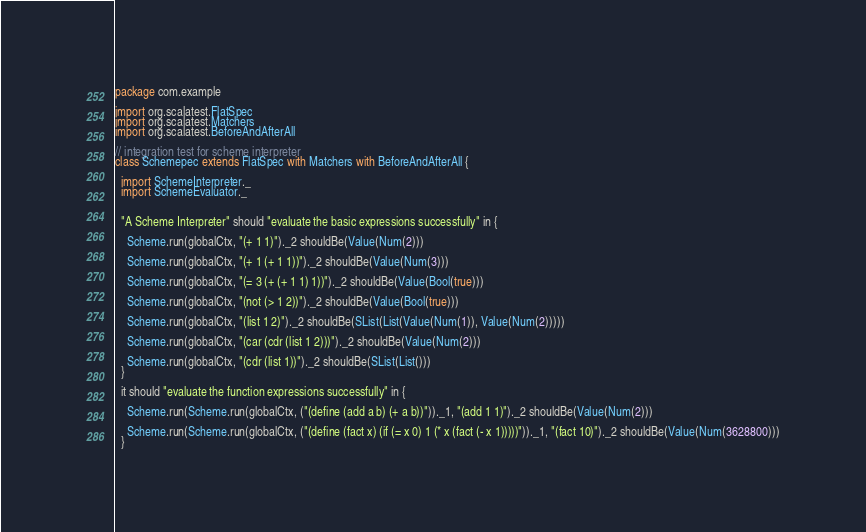Convert code to text. <code><loc_0><loc_0><loc_500><loc_500><_Scala_>package com.example

import org.scalatest.FlatSpec
import org.scalatest.Matchers
import org.scalatest.BeforeAndAfterAll

// integration test for scheme interpreter
class Schemepec extends FlatSpec with Matchers with BeforeAndAfterAll {

  import SchemeInterpreter._
  import SchemeEvaluator._


  "A Scheme Interpreter" should "evaluate the basic expressions successfully" in {

    Scheme.run(globalCtx, "(+ 1 1)")._2 shouldBe(Value(Num(2)))

    Scheme.run(globalCtx, "(+ 1 (+ 1 1))")._2 shouldBe(Value(Num(3)))

    Scheme.run(globalCtx, "(= 3 (+ (+ 1 1) 1))")._2 shouldBe(Value(Bool(true)))

    Scheme.run(globalCtx, "(not (> 1 2))")._2 shouldBe(Value(Bool(true)))

    Scheme.run(globalCtx, "(list 1 2)")._2 shouldBe(SList(List(Value(Num(1)), Value(Num(2)))))

    Scheme.run(globalCtx, "(car (cdr (list 1 2)))")._2 shouldBe(Value(Num(2)))

    Scheme.run(globalCtx, "(cdr (list 1))")._2 shouldBe(SList(List()))
  }

  it should "evaluate the function expressions successfully" in {

    Scheme.run(Scheme.run(globalCtx, ("(define (add a b) (+ a b))"))._1, "(add 1 1)")._2 shouldBe(Value(Num(2)))
    
    Scheme.run(Scheme.run(globalCtx, ("(define (fact x) (if (= x 0) 1 (* x (fact (- x 1)))))"))._1, "(fact 10)")._2 shouldBe(Value(Num(3628800)))
  }
</code> 